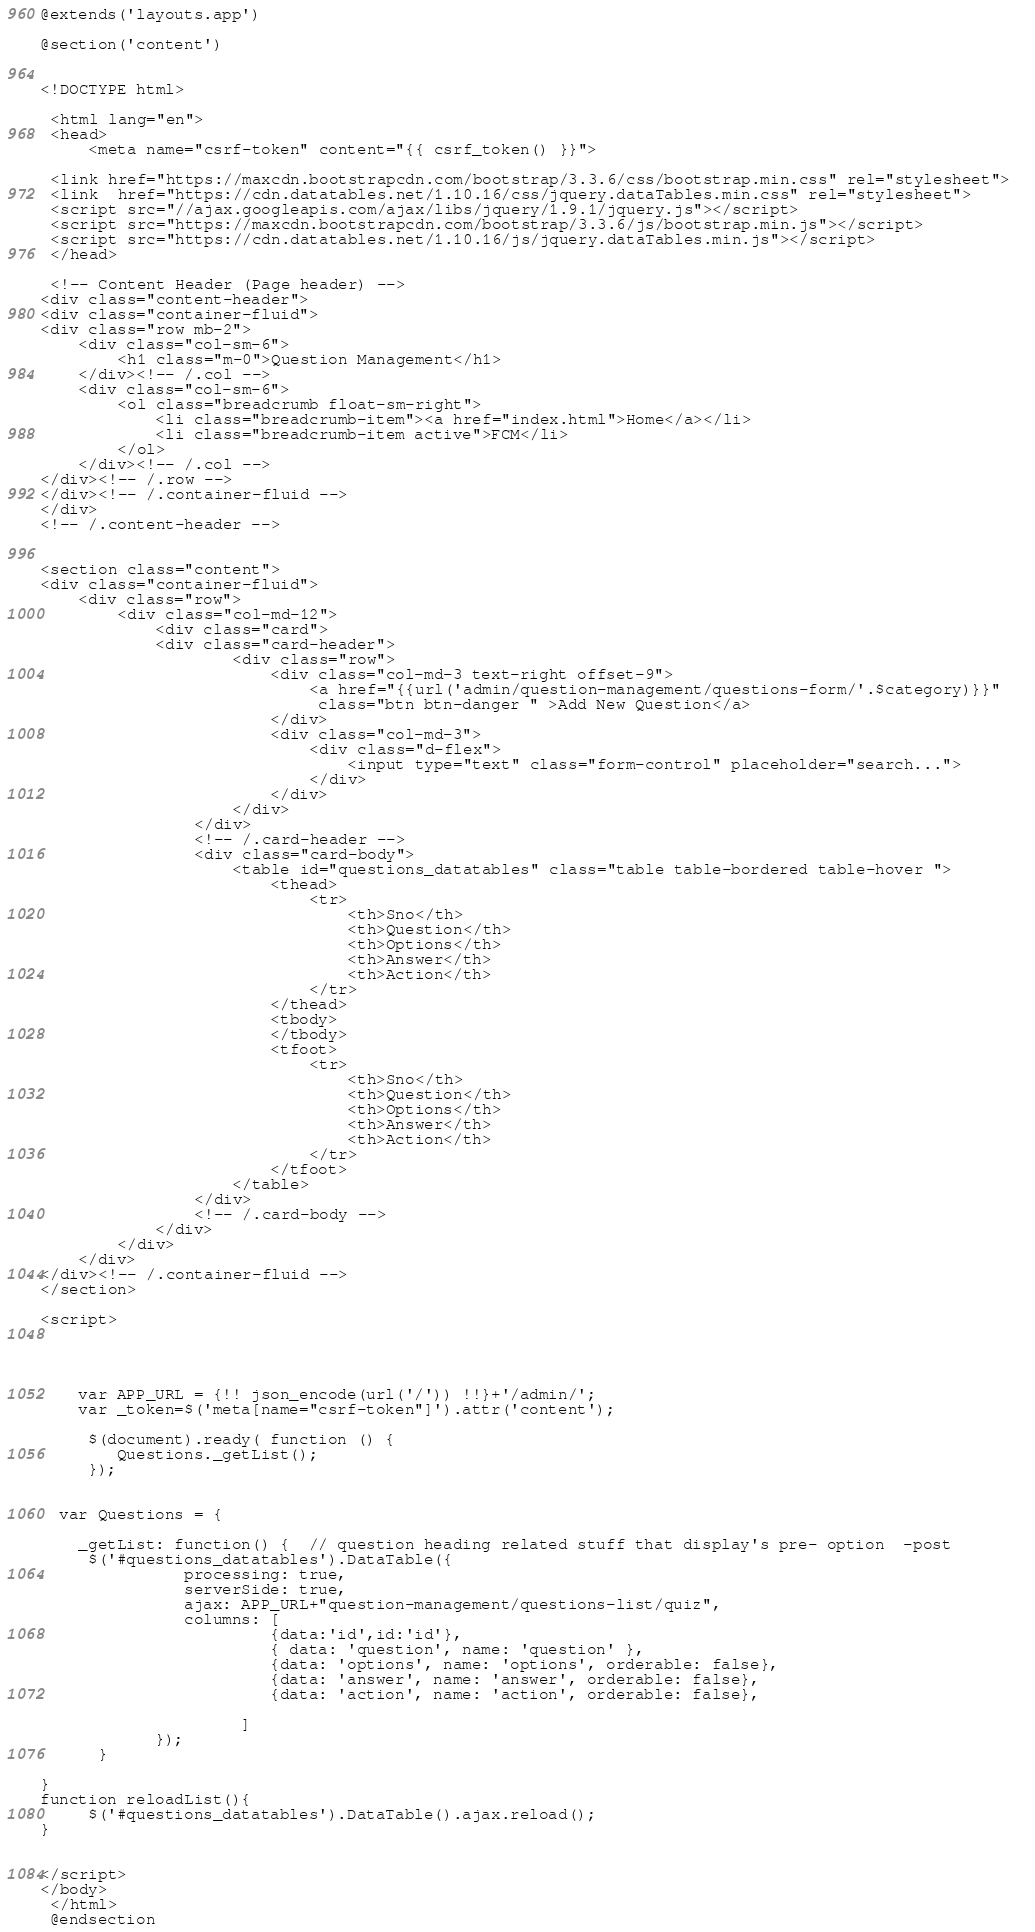Convert code to text. <code><loc_0><loc_0><loc_500><loc_500><_PHP_>@extends('layouts.app')

@section('content')


<!DOCTYPE html>
 
 <html lang="en">
 <head>    
     <meta name="csrf-token" content="{{ csrf_token() }}">

 <link href="https://maxcdn.bootstrapcdn.com/bootstrap/3.3.6/css/bootstrap.min.css" rel="stylesheet">  
 <link  href="https://cdn.datatables.net/1.10.16/css/jquery.dataTables.min.css" rel="stylesheet">
 <script src="//ajax.googleapis.com/ajax/libs/jquery/1.9.1/jquery.js"></script>  
 <script src="https://maxcdn.bootstrapcdn.com/bootstrap/3.3.6/js/bootstrap.min.js"></script>
 <script src="https://cdn.datatables.net/1.10.16/js/jquery.dataTables.min.js"></script>
 </head>

 <!-- Content Header (Page header) -->
<div class="content-header">
<div class="container-fluid">
<div class="row mb-2">
    <div class="col-sm-6">
        <h1 class="m-0">Question Management</h1>
    </div><!-- /.col -->
    <div class="col-sm-6">
        <ol class="breadcrumb float-sm-right">
            <li class="breadcrumb-item"><a href="index.html">Home</a></li>
            <li class="breadcrumb-item active">FCM</li>
        </ol>
    </div><!-- /.col -->
</div><!-- /.row -->
</div><!-- /.container-fluid -->
</div>
<!-- /.content-header -->


<section class="content">
<div class="container-fluid">
    <div class="row">
        <div class="col-md-12">
            <div class="card">
            <div class="card-header">
                    <div class="row">
                        <div class="col-md-3 text-right offset-9">
                            <a href="{{url('admin/question-management/questions-form/'.$category)}}"  
                             class="btn btn-danger " >Add New Question</a>
                        </div>
                        <div class="col-md-3">
                            <div class="d-flex">
                                <input type="text" class="form-control" placeholder="search...">
                            </div>
                        </div>
                    </div>
                </div>
                <!-- /.card-header -->
                <div class="card-body">
                    <table id="questions_datatables" class="table table-bordered table-hover ">
                        <thead>
                            <tr>
                                <th>Sno</th>
                                <th>Question</th>
                                <th>Options</th>
                                <th>Answer</th>
                                <th>Action</th>
                            </tr>
                        </thead>
                        <tbody>
                        </tbody>
                        <tfoot>
                            <tr>
                                <th>Sno</th>
                                <th>Question</th>
                                <th>Options</th>
                                <th>Answer</th>
                                <th>Action</th>
                            </tr>
                        </tfoot>
                    </table>
                </div>
                <!-- /.card-body -->
            </div>
        </div>
    </div>
</div><!-- /.container-fluid -->
</section>
   
<script>




    var APP_URL = {!! json_encode(url('/')) !!}+'/admin/';
    var _token=$('meta[name="csrf-token"]').attr('content');

     $(document).ready( function () {
        Questions._getList();
     });

    
  var Questions = {
  
    _getList: function() {  // question heading related stuff that display's pre- option  -post
     $('#questions_datatables').DataTable({
               processing: true,
               serverSide: true,
               ajax: APP_URL+"question-management/questions-list/quiz",
               columns: [
                        {data:'id',id:'id'},
                        { data: 'question', name: 'question' },
                        {data: 'options', name: 'options', orderable: false},
                        {data: 'answer', name: 'answer', orderable: false},
                        {data: 'action', name: 'action', orderable: false},

                     ]
            });
      }

}
function reloadList(){
     $('#questions_datatables').DataTable().ajax.reload();
}


</script>
</body>
 </html> 
 @endsection
</code> 